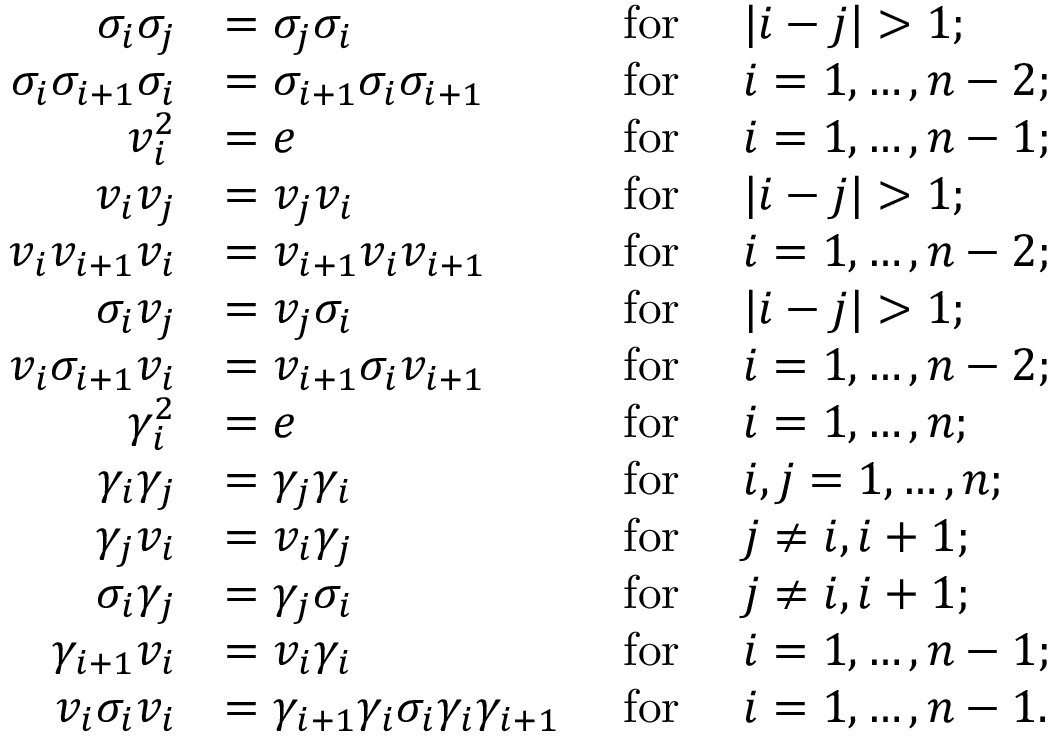Convert formula to latex. <formula><loc_0><loc_0><loc_500><loc_500>\begin{array} { r l r l } { \sigma _ { i } \sigma _ { j } } & { = \sigma _ { j } \sigma _ { i } } & { f o r } & { | i - j | > 1 ; } \\ { \sigma _ { i } \sigma _ { i + 1 } \sigma _ { i } } & { = \sigma _ { i + 1 } \sigma _ { i } \sigma _ { i + 1 } } & { f o r } & { i = 1 , \dots , n - 2 ; } \\ { v _ { i } ^ { 2 } } & { = e } & { f o r } & { i = 1 , \dots , n - 1 ; } \\ { v _ { i } v _ { j } } & { = v _ { j } v _ { i } } & { f o r } & { | i - j | > 1 ; } \\ { v _ { i } v _ { i + 1 } v _ { i } } & { = v _ { i + 1 } v _ { i } v _ { i + 1 } } & { f o r } & { i = 1 , \dots , n - 2 ; } \\ { \sigma _ { i } v _ { j } } & { = v _ { j } \sigma _ { i } } & { f o r } & { | i - j | > 1 ; } \\ { v _ { i } \sigma _ { i + 1 } v _ { i } } & { = v _ { i + 1 } \sigma _ { i } v _ { i + 1 } } & { f o r } & { i = 1 , \dots , n - 2 ; } \\ { \gamma _ { i } ^ { 2 } } & { = e } & { f o r } & { i = 1 , \dots , n ; } \\ { \gamma _ { i } \gamma _ { j } } & { = \gamma _ { j } \gamma _ { i } } & { f o r } & { i , j = 1 , \dots , n ; } \\ { \gamma _ { j } v _ { i } } & { = v _ { i } \gamma _ { j } } & { f o r } & { j \neq i , i + 1 ; } \\ { \sigma _ { i } \gamma _ { j } } & { = \gamma _ { j } \sigma _ { i } } & { f o r } & { j \neq i , i + 1 ; } \\ { \gamma _ { i + 1 } v _ { i } } & { = v _ { i } \gamma _ { i } } & { f o r } & { i = 1 , \dots , n - 1 ; } \\ { v _ { i } \sigma _ { i } v _ { i } } & { = \gamma _ { i + 1 } \gamma _ { i } \sigma _ { i } \gamma _ { i } \gamma _ { i + 1 } } & { f o r } & { i = 1 , \dots , n - 1 . } \end{array}</formula> 